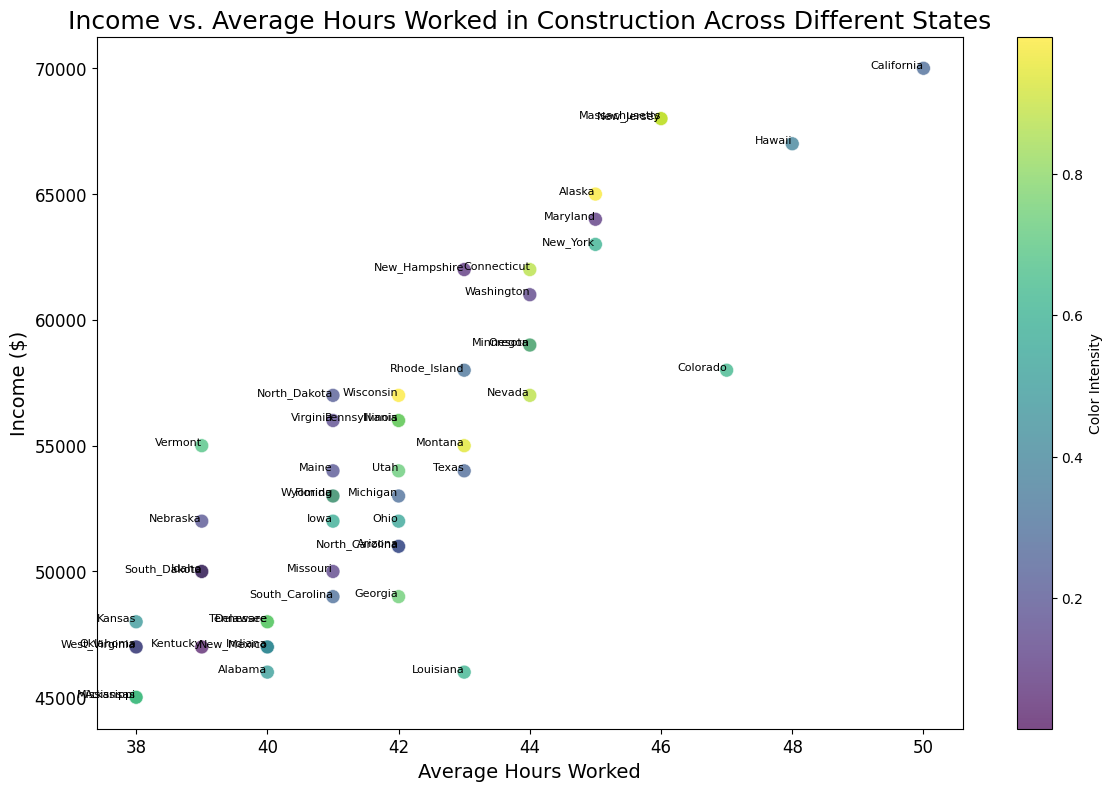Which state has the highest income? By referring to the y-axis, we can find the highest point, which corresponds to the highest income figure. The state label for this point is California.
Answer: California Which state works the most hours on average? By referring to the x-axis, we can find the farthest point to the right, which corresponds to the most hours worked. The state label for this point is California.
Answer: California How many states have an average income above $60,000? By looking at the y-axis, identify the points above the $60,000 mark. Counting these points, we find there are seven states (California, Alaska, Connecticut, Maryland, Massachusetts, New Jersey, New York) above this threshold.
Answer: 7 Which state has the lowest number of hours worked on average? By referring to the x-axis, we can find the farthest point to the left, which corresponds to the fewest hours worked. The state label for this point is Arkansas and Mississippi.
Answer: Arkansas and Mississippi Is there a state that works fewer hours than Alabama and also earns a higher income? Alabama works 40 hours and earns $46,000. By comparing other points, we find Colorado and Connecticut work 38-39 hours while earning more than Alabama.
Answer: Yes, Colorado and Connecticut Compare the incomes of Rhode Island and Virginia. Which state earns more, and by how much? Identify the points for both states and compare their income values on the y-axis: Rhode Island ($58,000) and Virginia ($56,000). The difference is $2,000.
Answer: Rhode Island earns $2,000 more Which state has the color with the highest intensity in the plot, and what does the color represent? By observing the color intensity on the scatter plot points, we find the state with the brightest color. This is subjective to color perception and the color map used, but in this specific plot, it could be states such as California. The color represents random values assigned to each state.
Answer: California (example) For states where the average hours worked are 42, what is their range of incomes? Identify points on the x-axis where the value is 42 and check the range of y-axis incomes. The states with 42 hours are Arizona, Florida, Georgia, Illinois, Michigan, North Carolina, Ohio, Pennsylvania, and Wisconsin, with incomes ranging from $47,000 to $56,000.
Answer: $47,000 to $56,000 What is the average income of the states working 39 hours? Identify the points on the x-axis with 39 hours (Idaho, Kentucky, South Dakota, Nebraska, Vermont) and calculate their average income: ($50,000 + $47,000 + $50,000 + $52,000 + $55,000) / 5. The sum is $254,000, hence the average is $50,800.
Answer: $50,800 Which states fall within the range of 41 to 44 hours worked and earn more than $60,000? By identifying points within the 41-44 hours worked on the x-axis and checking their y-axis values for incomes above $60,000, we find the states are Connecticut, Maryland, and Washington.
Answer: Connecticut, Maryland, and Washington 